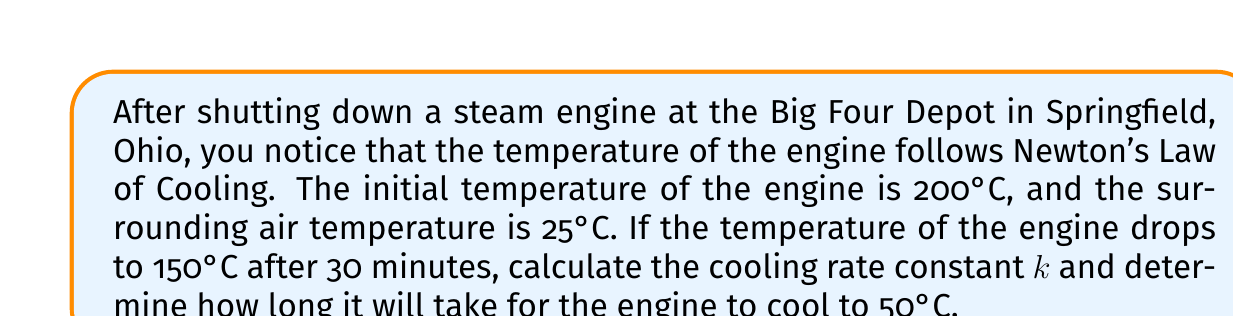Show me your answer to this math problem. Let's approach this problem step-by-step using Newton's Law of Cooling:

1) Newton's Law of Cooling is given by the differential equation:

   $$\frac{dT}{dt} = -k(T - T_s)$$

   where $T$ is the temperature of the object, $T_s$ is the surrounding temperature, $t$ is time, and $k$ is the cooling rate constant.

2) The solution to this differential equation is:

   $$T(t) = T_s + (T_0 - T_s)e^{-kt}$$

   where $T_0$ is the initial temperature.

3) Given:
   - Initial temperature $T_0 = 200°C$
   - Surrounding temperature $T_s = 25°C$
   - After 30 minutes (0.5 hours), temperature $T = 150°C$

4) Let's find $k$ using the equation from step 2:

   $$150 = 25 + (200 - 25)e^{-k(0.5)}$$

5) Simplify:
   $$125 = 175e^{-0.5k}$$

6) Divide both sides by 175:
   $$\frac{125}{175} = e^{-0.5k}$$

7) Take natural log of both sides:
   $$\ln(\frac{125}{175}) = -0.5k$$

8) Solve for $k$:
   $$k = -\frac{2}{0.5}\ln(\frac{125}{175}) \approx 0.6733 \text{ hr}^{-1}$$

9) Now, to find the time it takes to cool to 50°C, use the equation from step 2 again:

   $$50 = 25 + (200 - 25)e^{-0.6733t}$$

10) Simplify:
    $$25 = 175e^{-0.6733t}$$

11) Divide both sides by 175:
    $$\frac{1}{7} = e^{-0.6733t}$$

12) Take natural log of both sides:
    $$\ln(\frac{1}{7}) = -0.6733t$$

13) Solve for $t$:
    $$t = -\frac{\ln(\frac{1}{7})}{0.6733} \approx 2.9127 \text{ hours}$$
Answer: The cooling rate constant $k$ is approximately 0.6733 hr$^{-1}$, and it will take approximately 2.91 hours for the engine to cool to 50°C. 